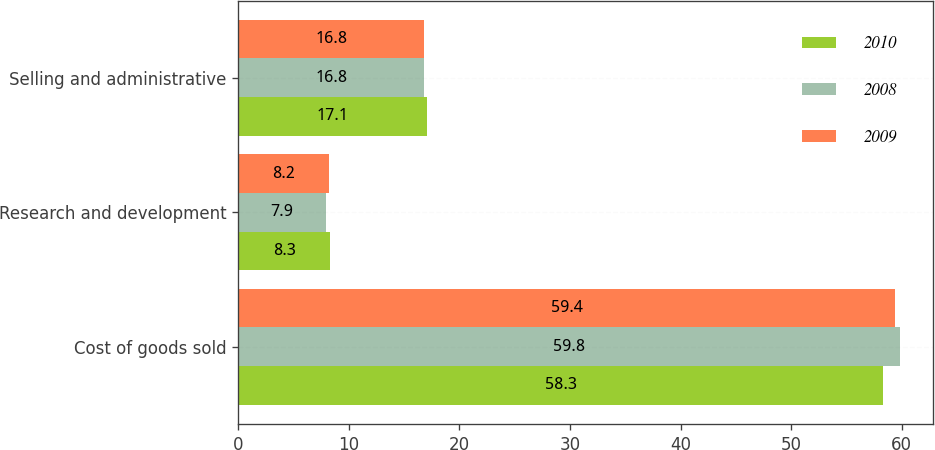Convert chart to OTSL. <chart><loc_0><loc_0><loc_500><loc_500><stacked_bar_chart><ecel><fcel>Cost of goods sold<fcel>Research and development<fcel>Selling and administrative<nl><fcel>2010<fcel>58.3<fcel>8.3<fcel>17.1<nl><fcel>2008<fcel>59.8<fcel>7.9<fcel>16.8<nl><fcel>2009<fcel>59.4<fcel>8.2<fcel>16.8<nl></chart> 